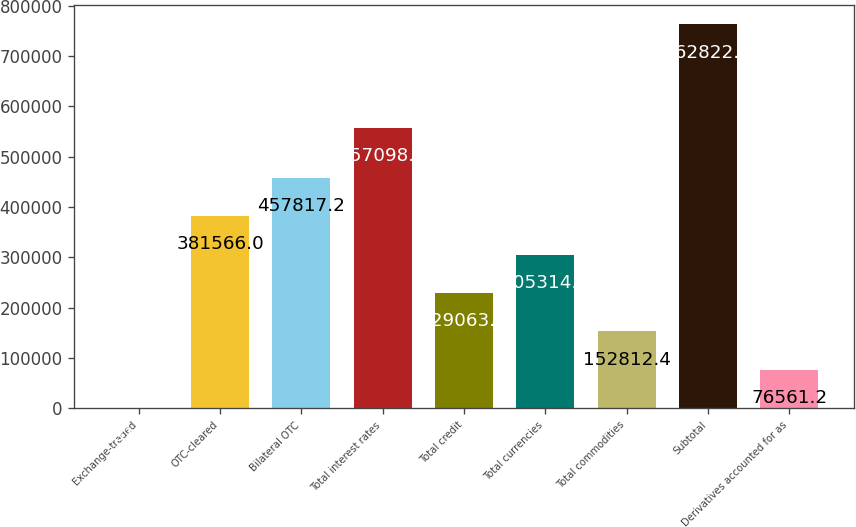Convert chart. <chart><loc_0><loc_0><loc_500><loc_500><bar_chart><fcel>Exchange-traded<fcel>OTC-cleared<fcel>Bilateral OTC<fcel>Total interest rates<fcel>Total credit<fcel>Total currencies<fcel>Total commodities<fcel>Subtotal<fcel>Derivatives accounted for as<nl><fcel>310<fcel>381566<fcel>457817<fcel>557098<fcel>229064<fcel>305315<fcel>152812<fcel>762822<fcel>76561.2<nl></chart> 